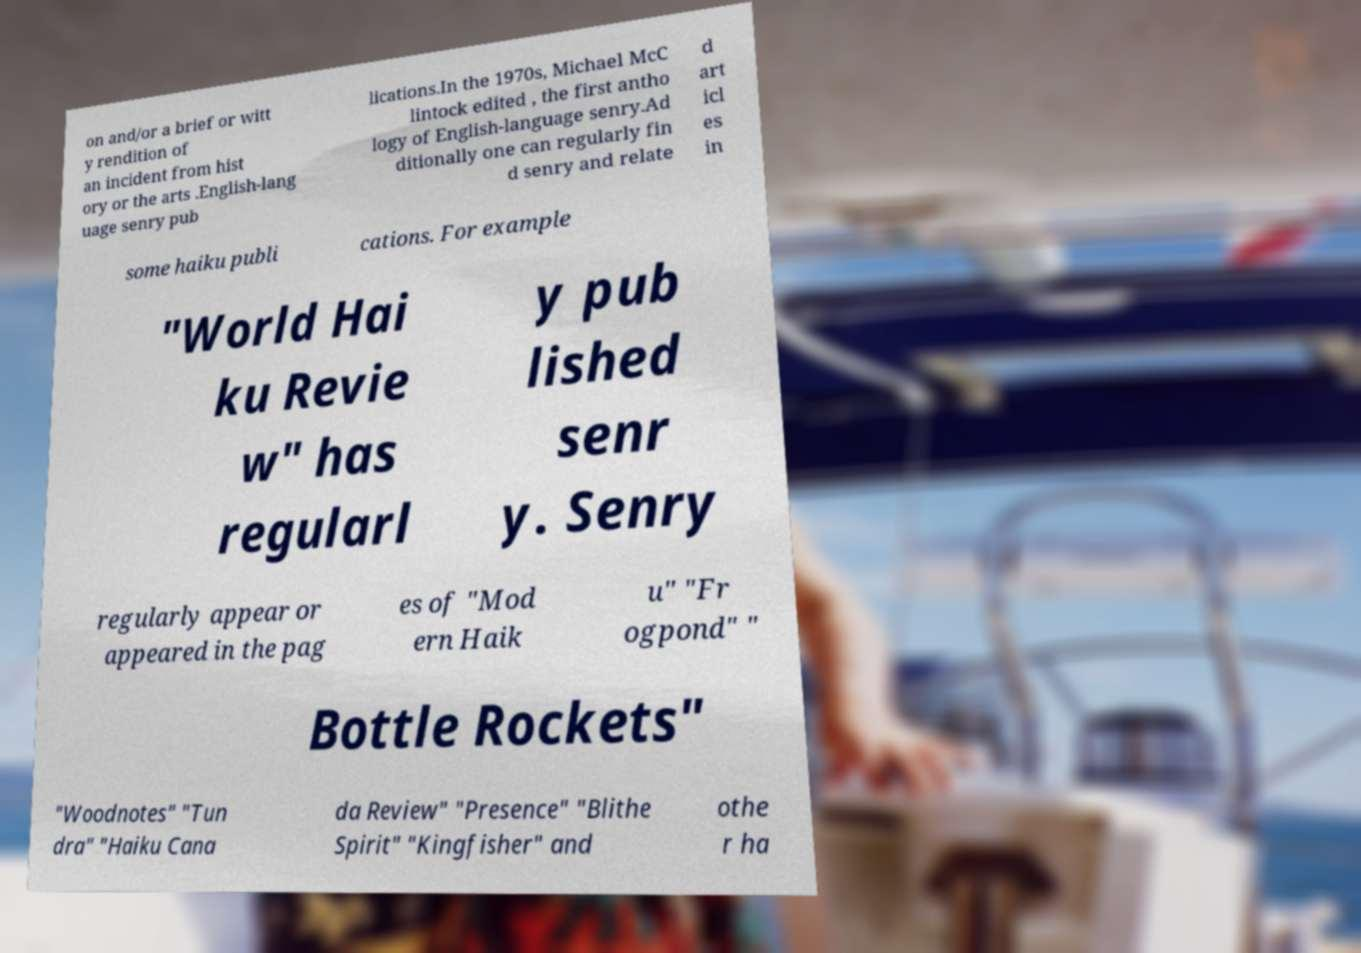Could you extract and type out the text from this image? on and/or a brief or witt y rendition of an incident from hist ory or the arts .English-lang uage senry pub lications.In the 1970s, Michael McC lintock edited , the first antho logy of English-language senry.Ad ditionally one can regularly fin d senry and relate d art icl es in some haiku publi cations. For example "World Hai ku Revie w" has regularl y pub lished senr y. Senry regularly appear or appeared in the pag es of "Mod ern Haik u" "Fr ogpond" " Bottle Rockets" "Woodnotes" "Tun dra" "Haiku Cana da Review" "Presence" "Blithe Spirit" "Kingfisher" and othe r ha 